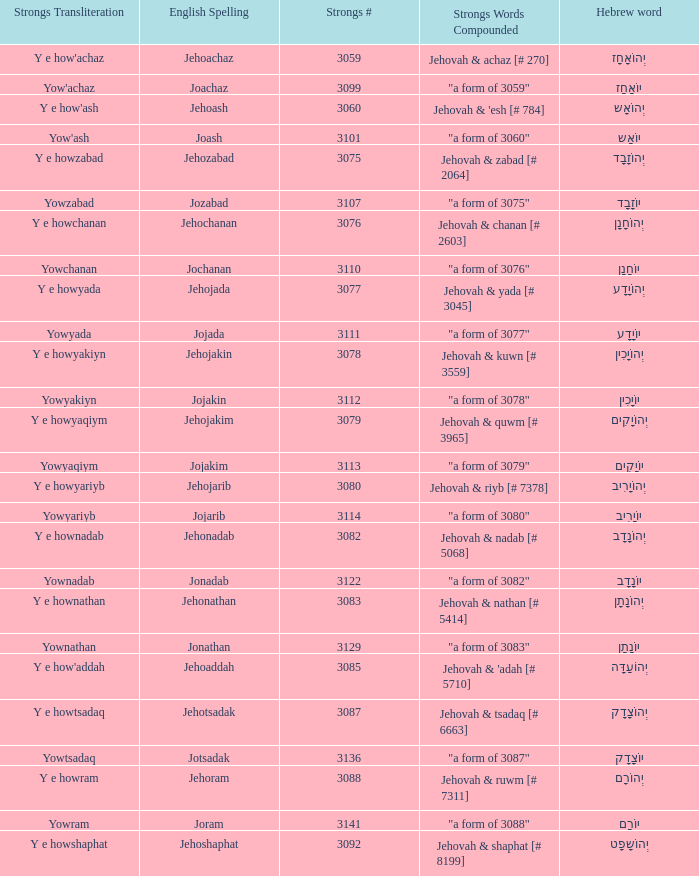What is the strongs words compounded when the english spelling is jonadab? "a form of 3082". 